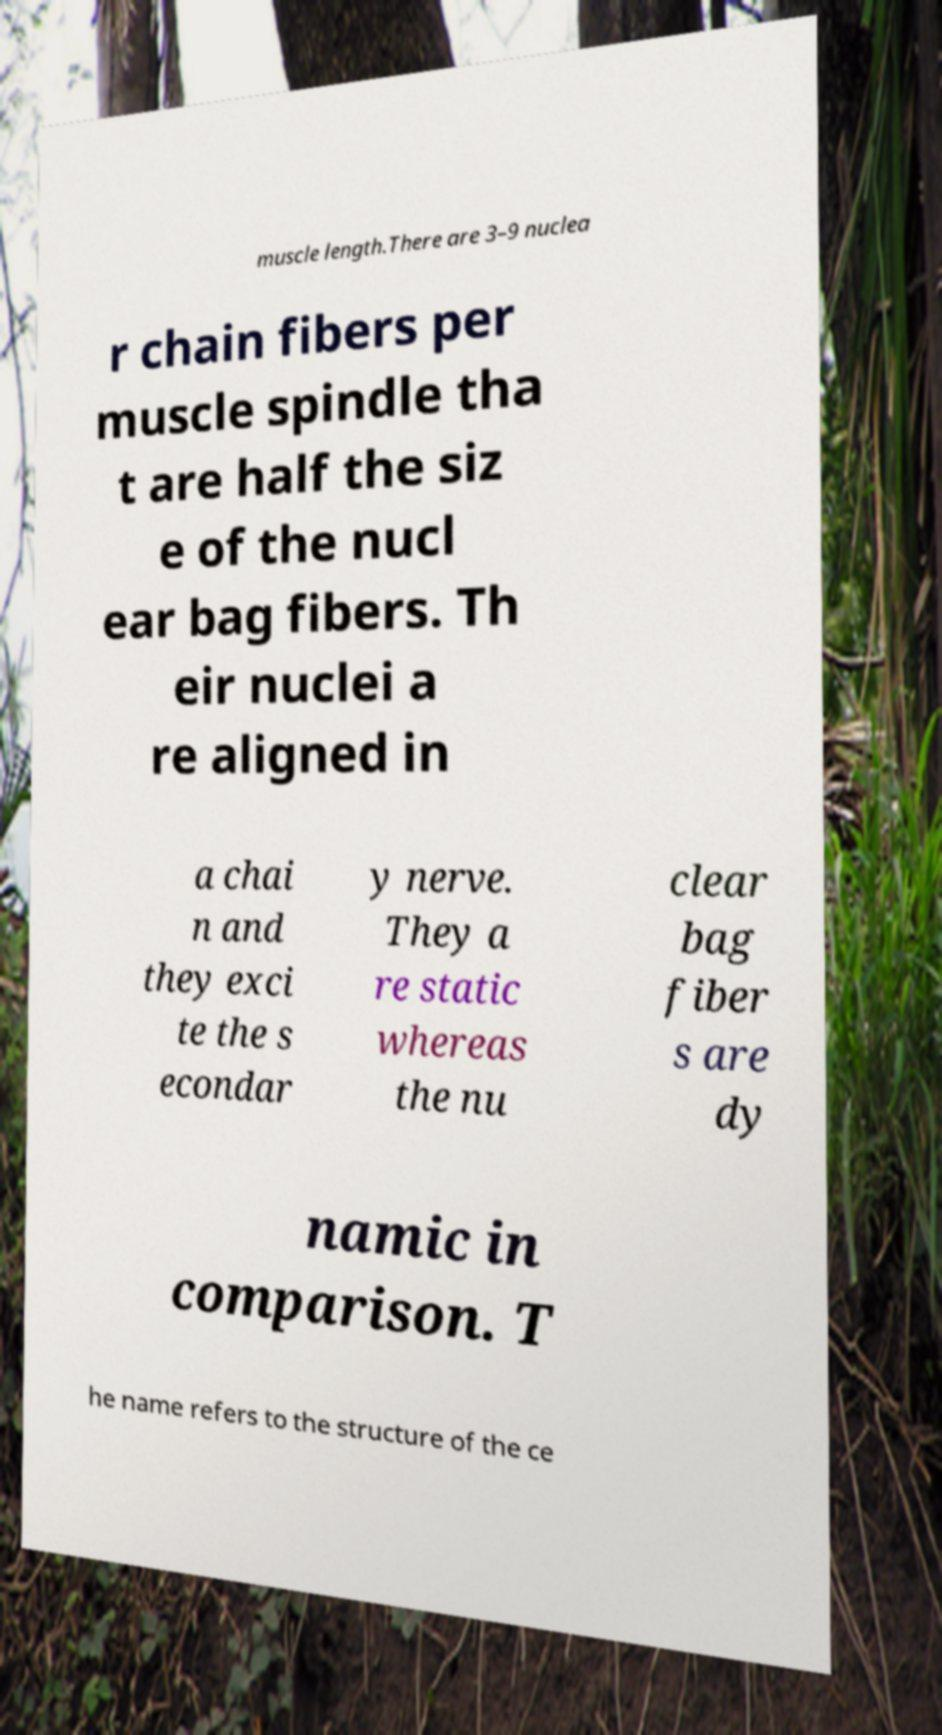What messages or text are displayed in this image? I need them in a readable, typed format. muscle length.There are 3–9 nuclea r chain fibers per muscle spindle tha t are half the siz e of the nucl ear bag fibers. Th eir nuclei a re aligned in a chai n and they exci te the s econdar y nerve. They a re static whereas the nu clear bag fiber s are dy namic in comparison. T he name refers to the structure of the ce 